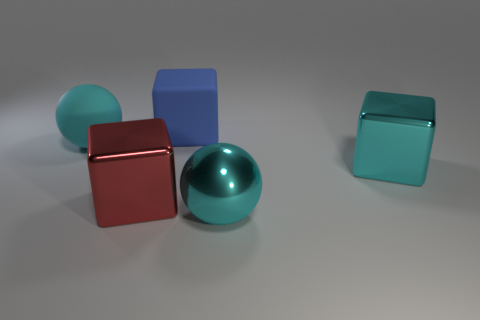Do the large blue object and the red shiny thing have the same shape?
Your answer should be very brief. Yes. What material is the other ball that is the same color as the large shiny sphere?
Ensure brevity in your answer.  Rubber. Are the cyan sphere that is behind the big cyan metallic cube and the sphere right of the large matte block made of the same material?
Make the answer very short. No. There is a blue cube that is the same size as the red block; what is its material?
Give a very brief answer. Rubber. There is a big cube right of the blue thing; is it the same color as the shiny thing that is in front of the red object?
Provide a succinct answer. Yes. Does the cyan object that is on the right side of the shiny ball have the same material as the red object?
Your response must be concise. Yes. Is there a large cyan ball on the right side of the large blue matte object behind the cyan rubber thing?
Make the answer very short. Yes. What is the material of the big blue thing that is the same shape as the red shiny object?
Provide a succinct answer. Rubber. Are there more big cyan things to the left of the large blue cube than balls left of the cyan matte thing?
Your answer should be very brief. Yes. What shape is the red object that is made of the same material as the cyan block?
Provide a succinct answer. Cube. 